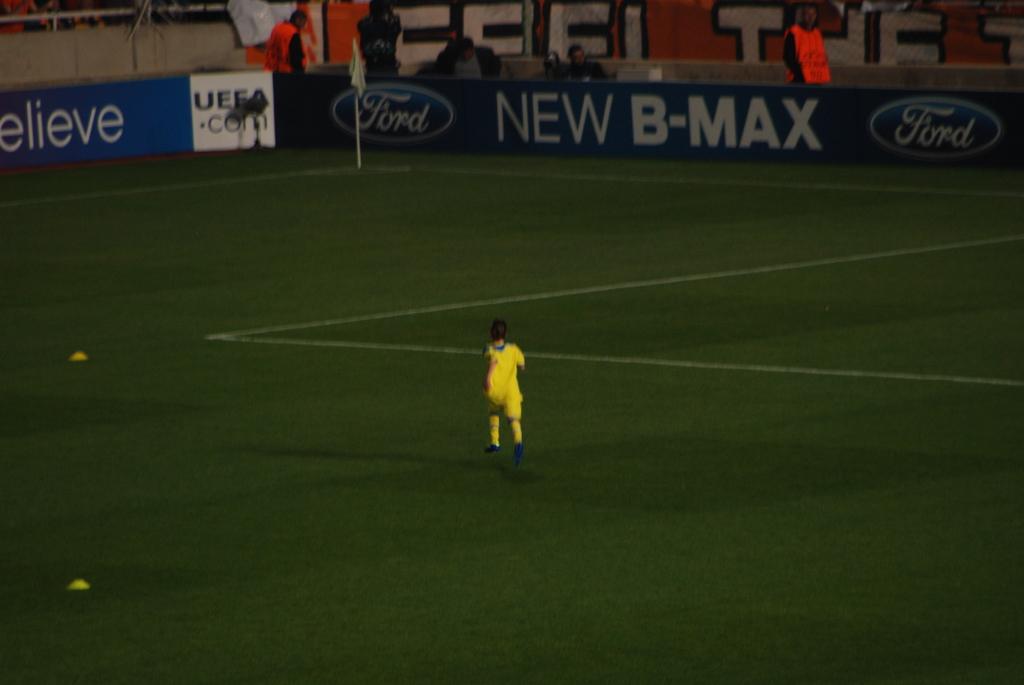What car brand is shown here?
Your answer should be very brief. Ford. What is ford advertising?
Give a very brief answer. New b-max. 